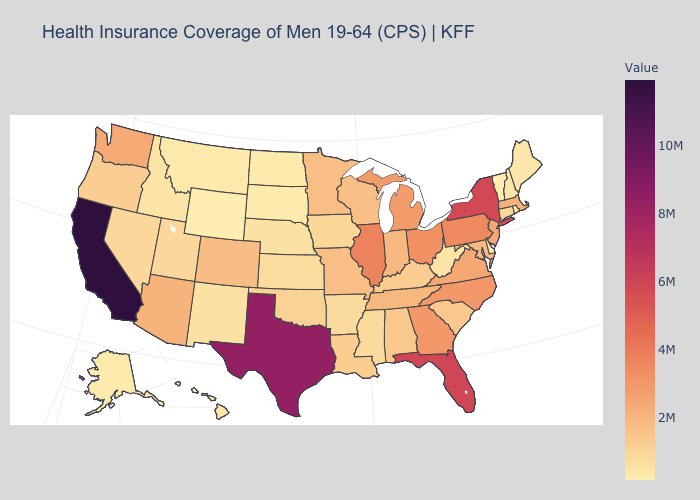Which states have the highest value in the USA?
Be succinct. California. Does Wyoming have the lowest value in the USA?
Concise answer only. Yes. Among the states that border New Mexico , which have the highest value?
Give a very brief answer. Texas. Does the map have missing data?
Short answer required. No. Which states have the lowest value in the MidWest?
Give a very brief answer. North Dakota. Which states have the lowest value in the West?
Write a very short answer. Wyoming. 